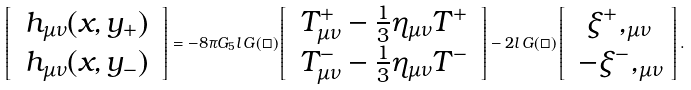<formula> <loc_0><loc_0><loc_500><loc_500>\left [ \begin{array} { c } \, h _ { \mu \nu } ( x , y _ { + } ) \, \\ \, h _ { \mu \nu } ( x , y _ { - } ) \, \end{array} \right ] = - 8 \pi G _ { 5 } l \, { G } ( \Box ) \left [ \begin{array} { c } \, T ^ { + } _ { \mu \nu } - \frac { 1 } { 3 } \eta _ { \mu \nu } T ^ { + } \, \\ \, T ^ { - } _ { \mu \nu } - \frac { 1 } { 3 } \eta _ { \mu \nu } T ^ { - } \, \end{array} \right ] - 2 l \, { G } ( \Box ) \left [ \begin{array} { c } \, \xi ^ { + } , _ { \mu \nu } \, \\ \, - \xi ^ { - } , _ { \mu \nu } \end{array} \right ] .</formula> 